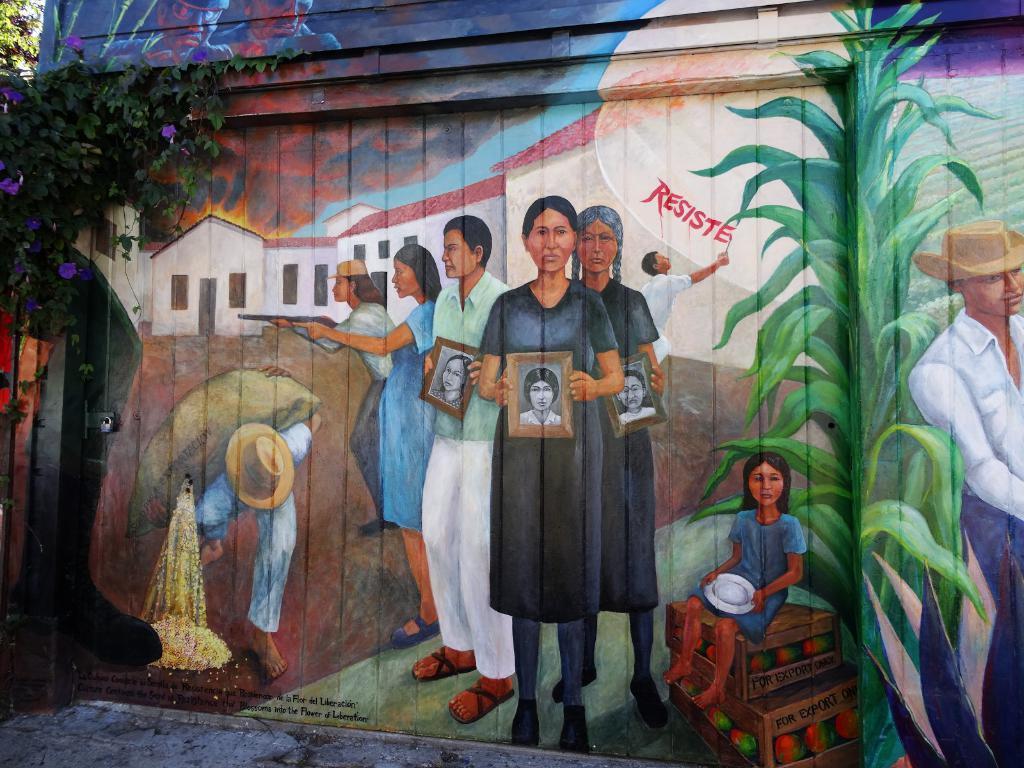Could you give a brief overview of what you see in this image? In this picture we can see painting on wooden wall. Here we can see group of persons standing near to the man who is sitting on the table. Here we can see a man who is wearing a white shirt, jeans and hat. On the top left corner we can see trees. 